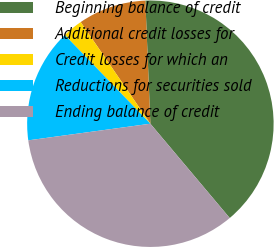Convert chart to OTSL. <chart><loc_0><loc_0><loc_500><loc_500><pie_chart><fcel>Beginning balance of credit<fcel>Additional credit losses for<fcel>Credit losses for which an<fcel>Reductions for securities sold<fcel>Ending balance of credit<nl><fcel>39.52%<fcel>8.92%<fcel>2.65%<fcel>14.94%<fcel>33.98%<nl></chart> 